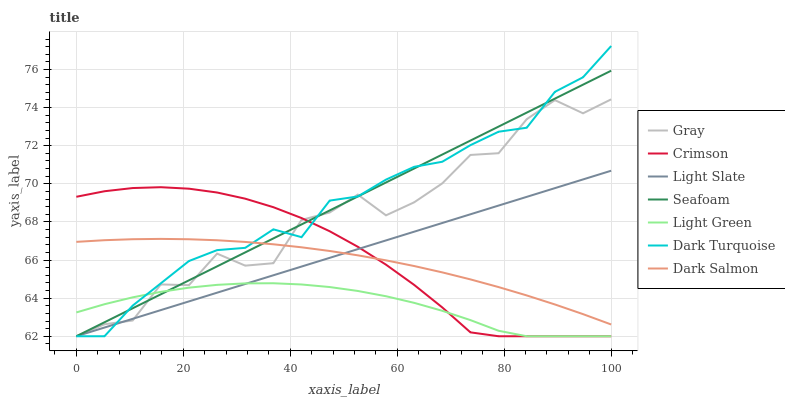Does Light Slate have the minimum area under the curve?
Answer yes or no. No. Does Light Slate have the maximum area under the curve?
Answer yes or no. No. Is Dark Turquoise the smoothest?
Answer yes or no. No. Is Dark Turquoise the roughest?
Answer yes or no. No. Does Dark Salmon have the lowest value?
Answer yes or no. No. Does Light Slate have the highest value?
Answer yes or no. No. Is Light Green less than Dark Salmon?
Answer yes or no. Yes. Is Dark Salmon greater than Light Green?
Answer yes or no. Yes. Does Light Green intersect Dark Salmon?
Answer yes or no. No. 